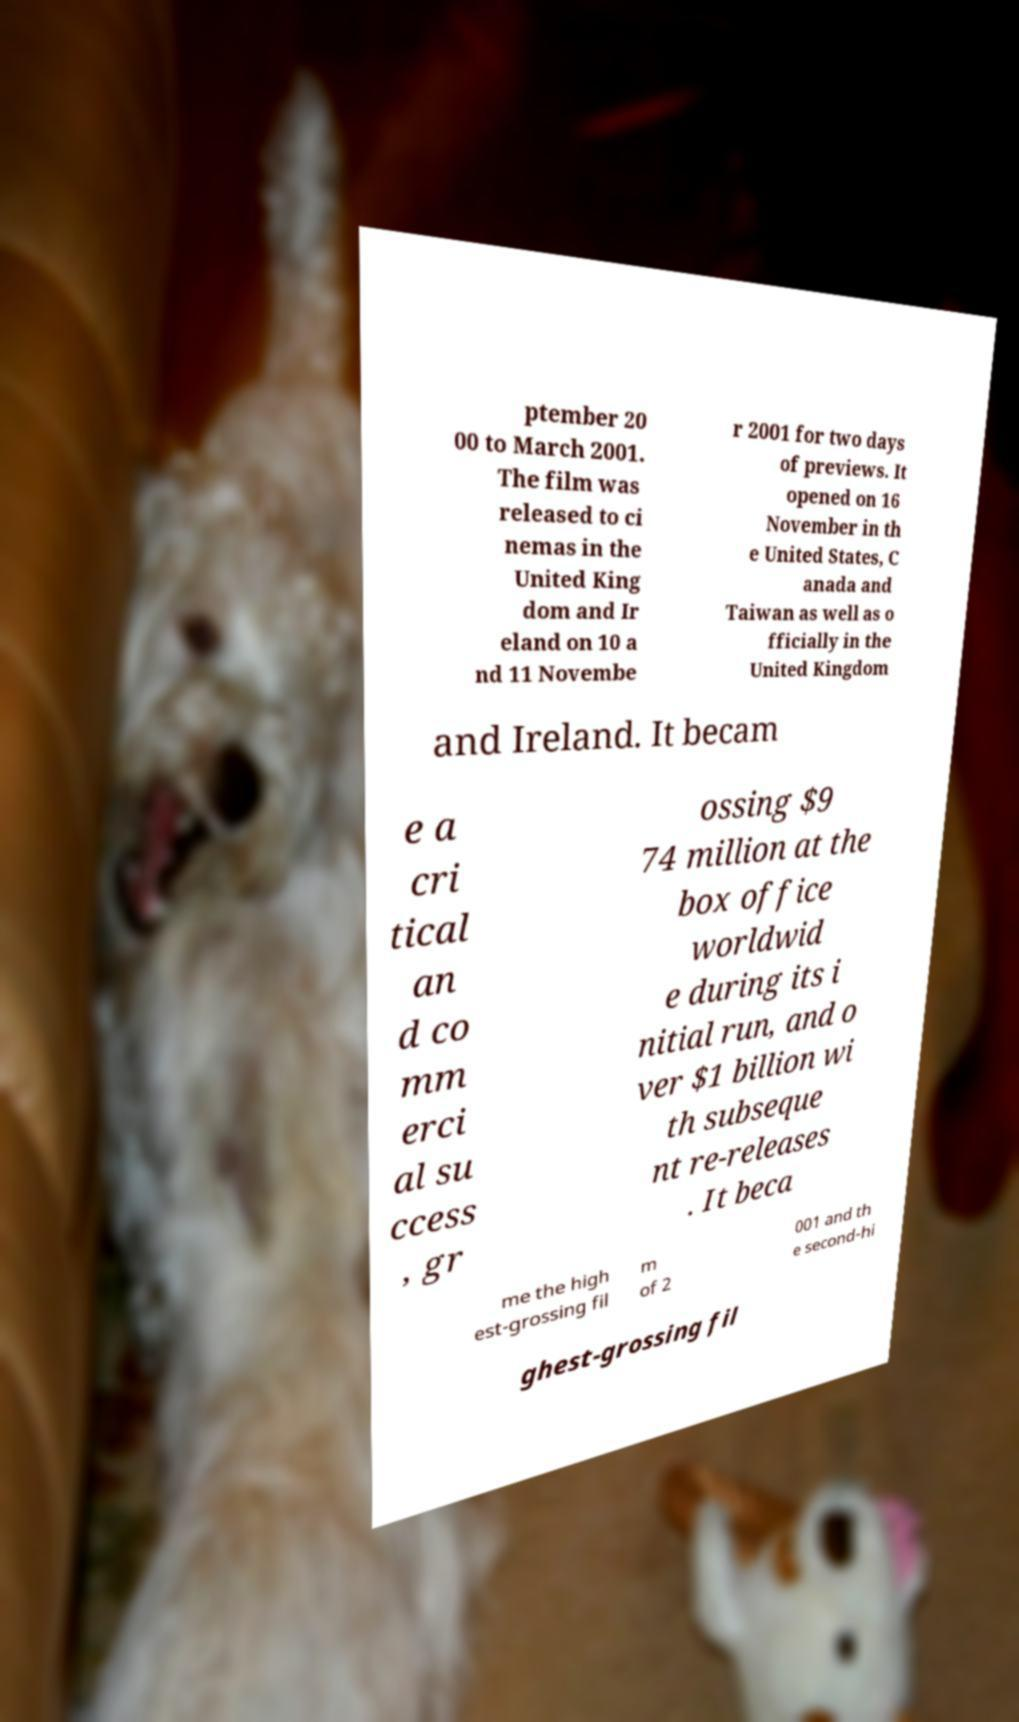Please read and relay the text visible in this image. What does it say? ptember 20 00 to March 2001. The film was released to ci nemas in the United King dom and Ir eland on 10 a nd 11 Novembe r 2001 for two days of previews. It opened on 16 November in th e United States, C anada and Taiwan as well as o fficially in the United Kingdom and Ireland. It becam e a cri tical an d co mm erci al su ccess , gr ossing $9 74 million at the box office worldwid e during its i nitial run, and o ver $1 billion wi th subseque nt re-releases . It beca me the high est-grossing fil m of 2 001 and th e second-hi ghest-grossing fil 